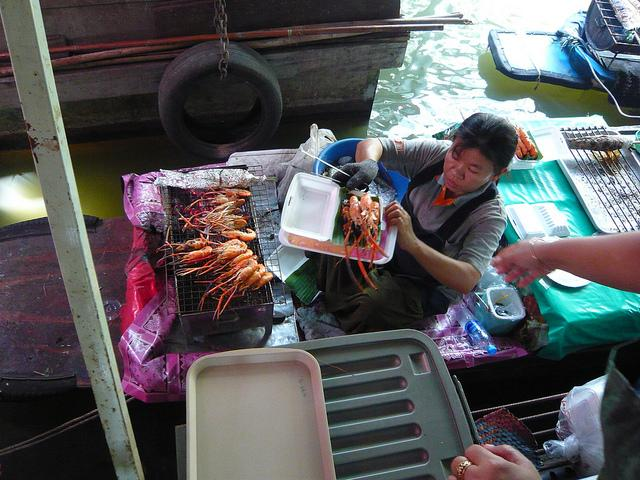What is this person's profession? chef 